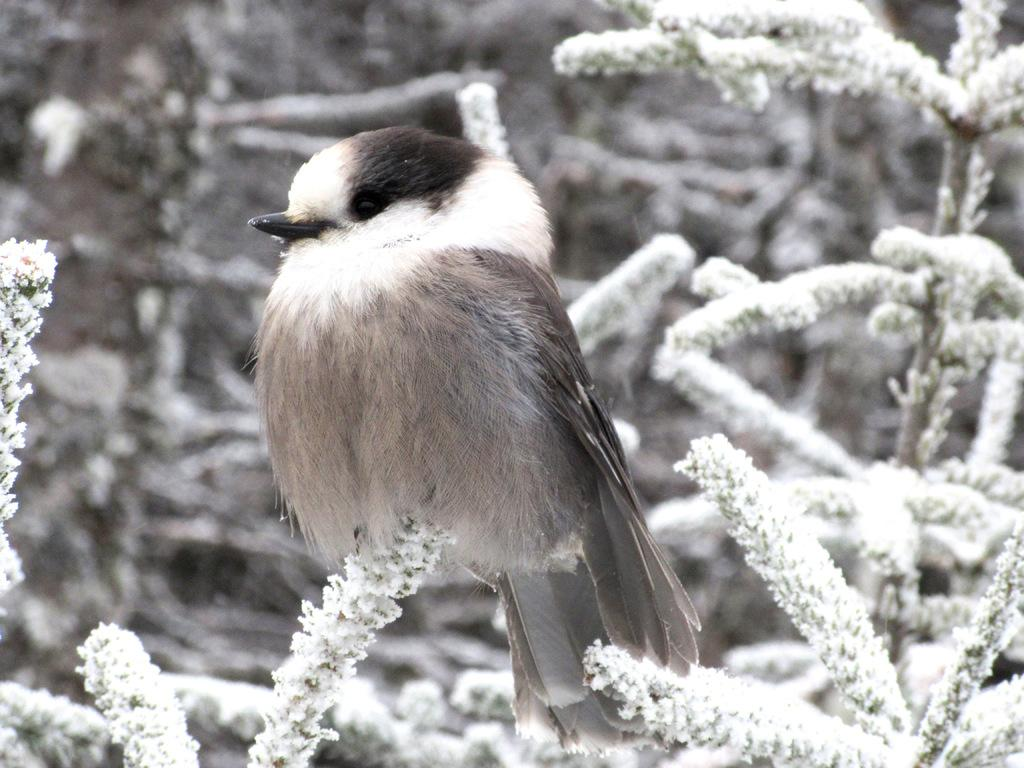What type of animal is in the image? There is a bird in the image. Where is the bird located? The bird is on a plant. What else can be seen in the image besides the bird? There are plants visible in the background of the image. What type of love can be seen between the bird and the goat in the image? There is no goat present in the image, and therefore no interaction between the bird and a goat can be observed. 